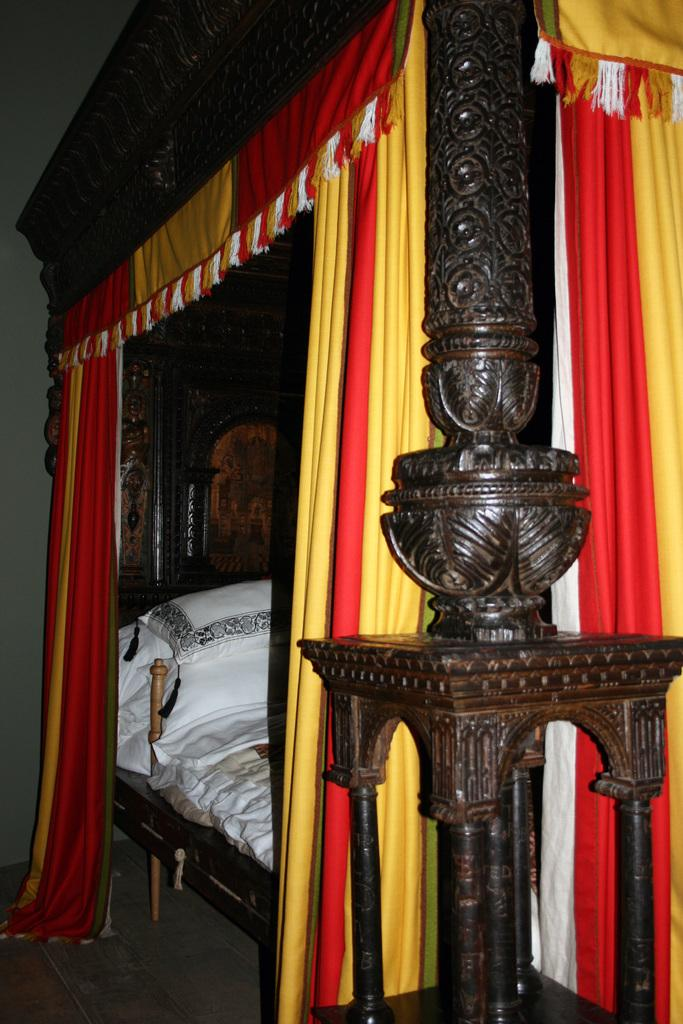What is located in the foreground of the image? There is a coat in the foreground of the image. What is placed on top of the coat? A pillow is visible on the coat. What other textile item can be seen in the image? There is a bed sheet in the image. What type of window treatment is present in the image? Curtains are present in the image. What architectural feature is visible in the image? There is a wall visible in the image. What type of fuel is being used to power the toothbrush in the image? There is no toothbrush present in the image, so it is not possible to determine what type of fuel it might use. 